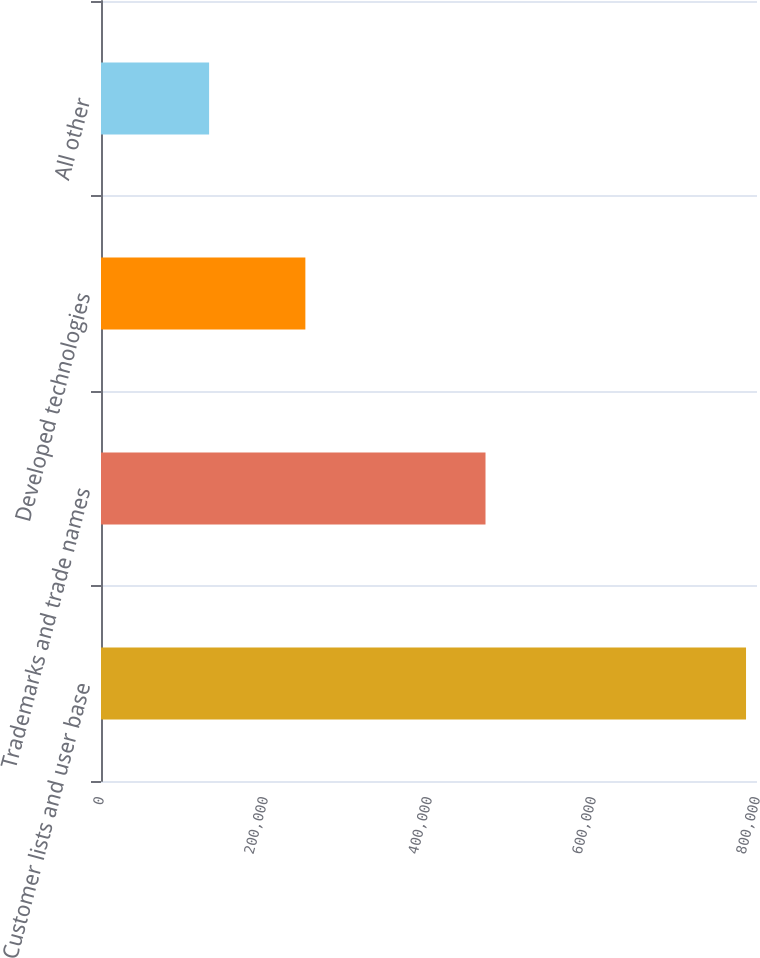Convert chart to OTSL. <chart><loc_0><loc_0><loc_500><loc_500><bar_chart><fcel>Customer lists and user base<fcel>Trademarks and trade names<fcel>Developed technologies<fcel>All other<nl><fcel>786623<fcel>468905<fcel>249228<fcel>131832<nl></chart> 